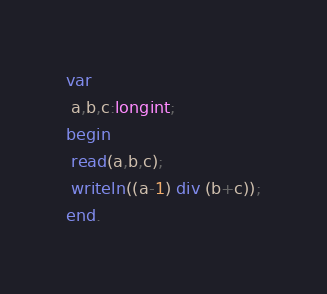<code> <loc_0><loc_0><loc_500><loc_500><_Pascal_>var
 a,b,c:longint;
begin
 read(a,b,c);
 writeln((a-1) div (b+c));
end.</code> 